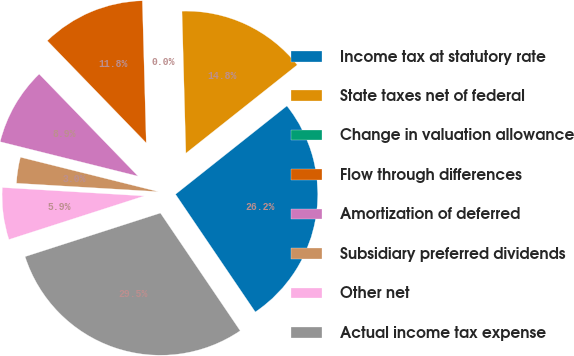<chart> <loc_0><loc_0><loc_500><loc_500><pie_chart><fcel>Income tax at statutory rate<fcel>State taxes net of federal<fcel>Change in valuation allowance<fcel>Flow through differences<fcel>Amortization of deferred<fcel>Subsidiary preferred dividends<fcel>Other net<fcel>Actual income tax expense<nl><fcel>26.19%<fcel>14.76%<fcel>0.0%<fcel>11.81%<fcel>8.86%<fcel>2.95%<fcel>5.9%<fcel>29.52%<nl></chart> 